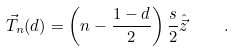Convert formula to latex. <formula><loc_0><loc_0><loc_500><loc_500>\vec { T } _ { n } ( d ) = \left ( n - \frac { 1 - d } { 2 } \right ) \frac { s } { 2 } \hat { \vec { z } } \quad .</formula> 